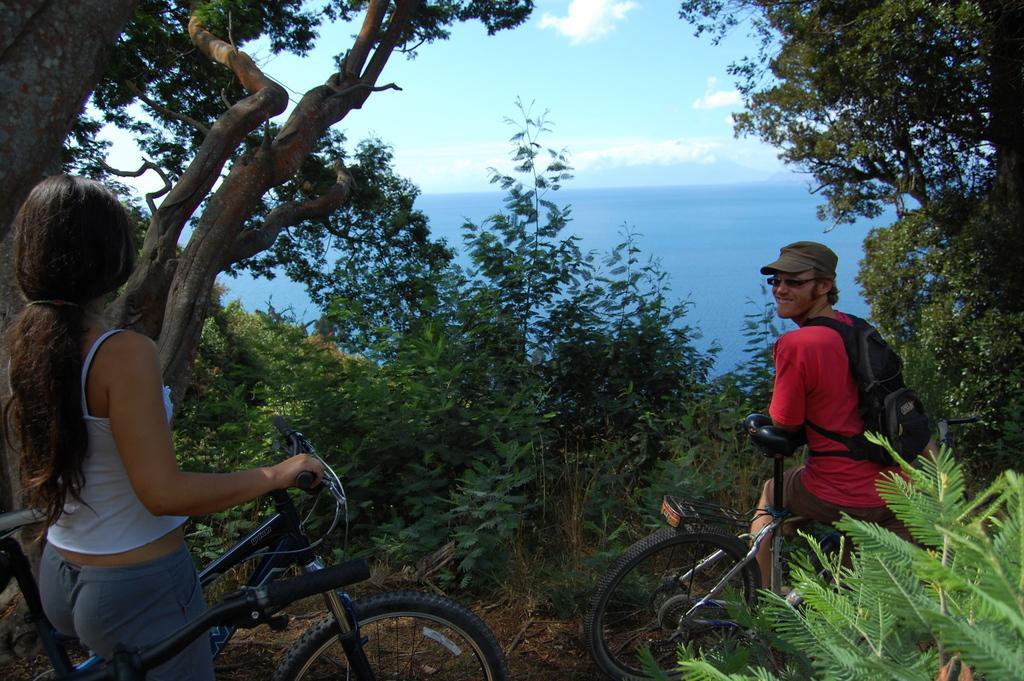Please provide a concise description of this image. In the image we can see two person, man and women they are riding a bicycle. This is a tree , water and cloudy sky. 